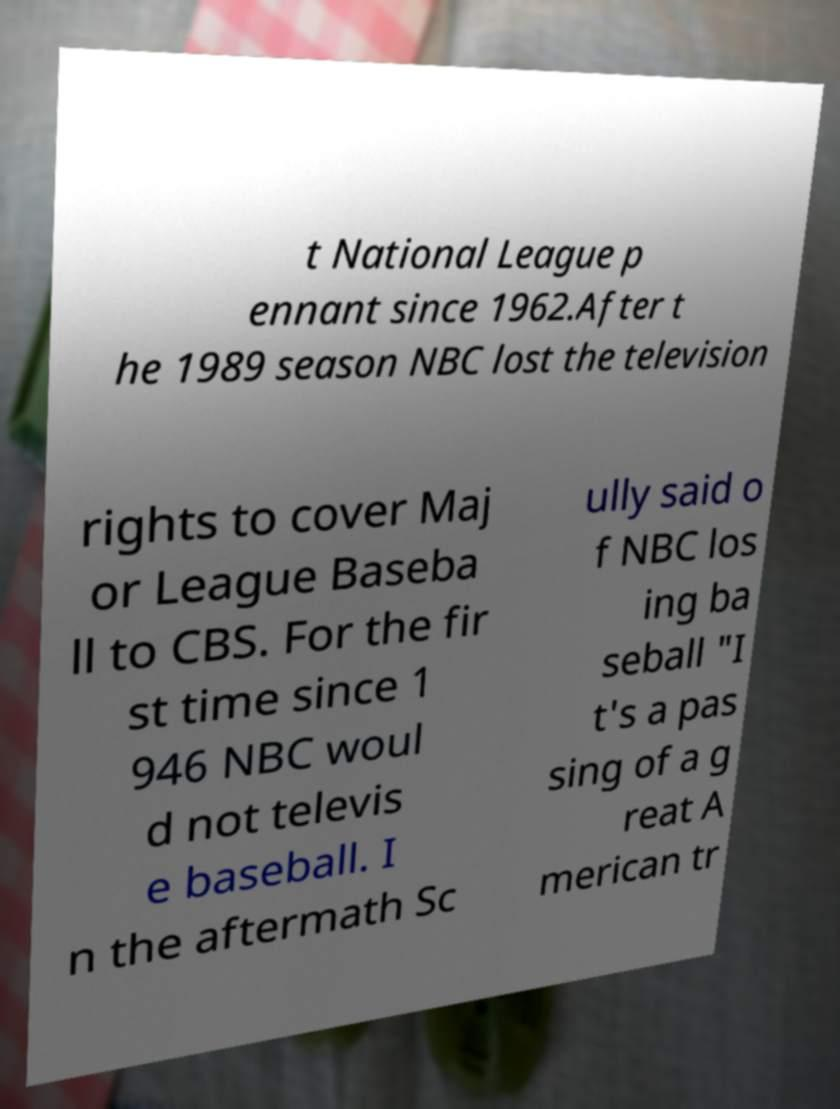Could you extract and type out the text from this image? t National League p ennant since 1962.After t he 1989 season NBC lost the television rights to cover Maj or League Baseba ll to CBS. For the fir st time since 1 946 NBC woul d not televis e baseball. I n the aftermath Sc ully said o f NBC los ing ba seball "I t's a pas sing of a g reat A merican tr 